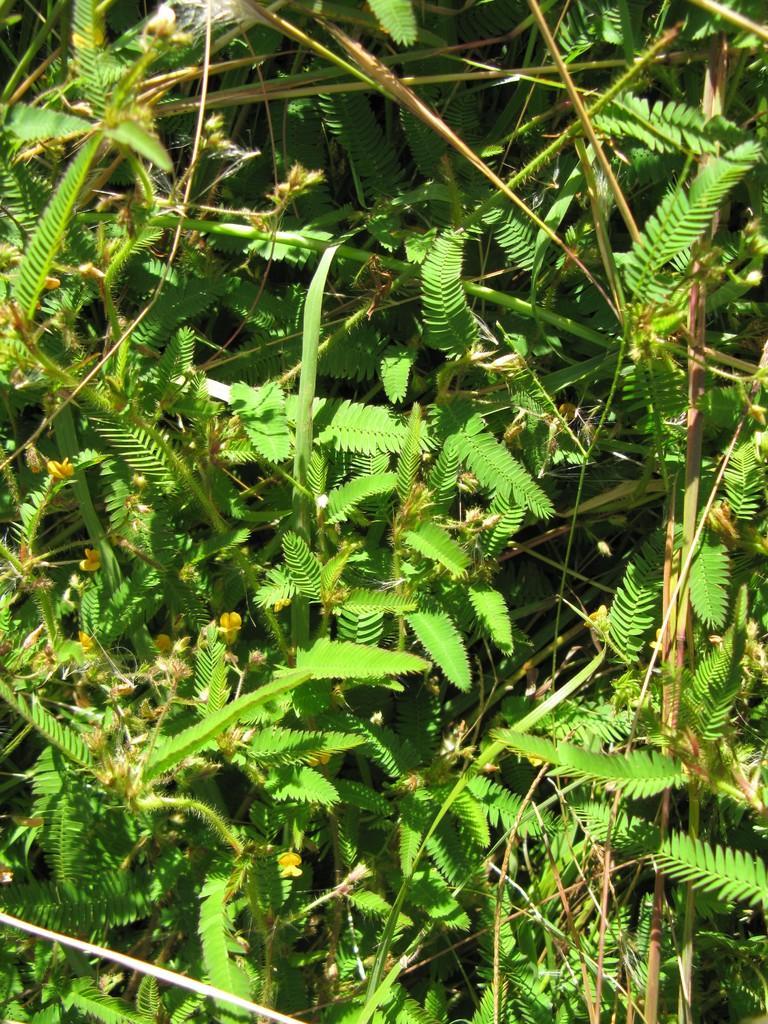Please provide a concise description of this image. In this image we can see the leaves of a touch me not plant. 